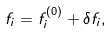Convert formula to latex. <formula><loc_0><loc_0><loc_500><loc_500>f _ { i } = f _ { i } ^ { ( 0 ) } + \delta f _ { i } ,</formula> 